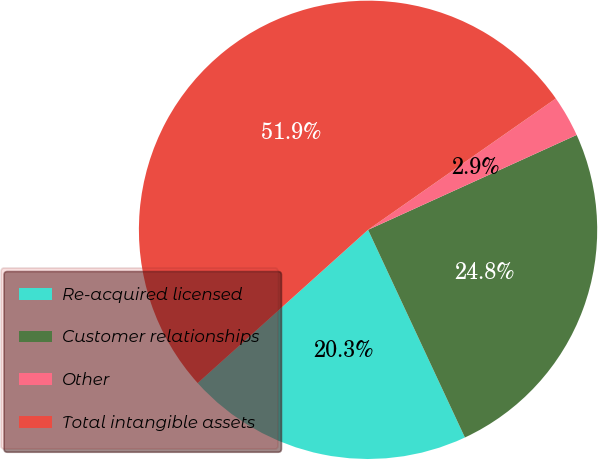Convert chart. <chart><loc_0><loc_0><loc_500><loc_500><pie_chart><fcel>Re-acquired licensed<fcel>Customer relationships<fcel>Other<fcel>Total intangible assets<nl><fcel>20.29%<fcel>24.85%<fcel>2.92%<fcel>51.95%<nl></chart> 